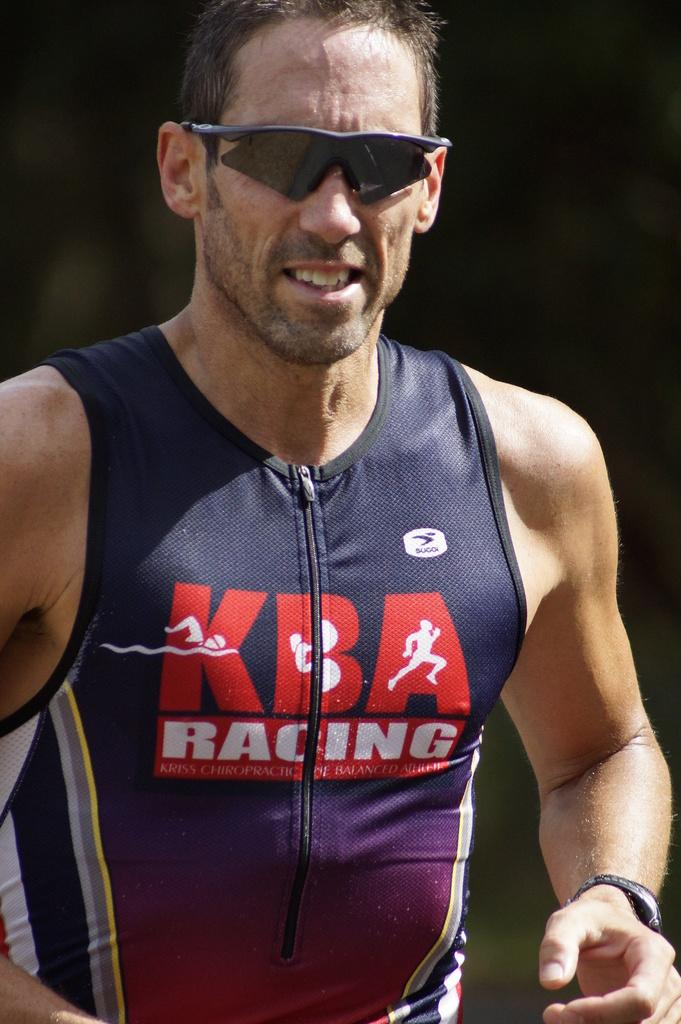<image>
Provide a brief description of the given image. a man with a KBA shirt on that has the word racing on it 